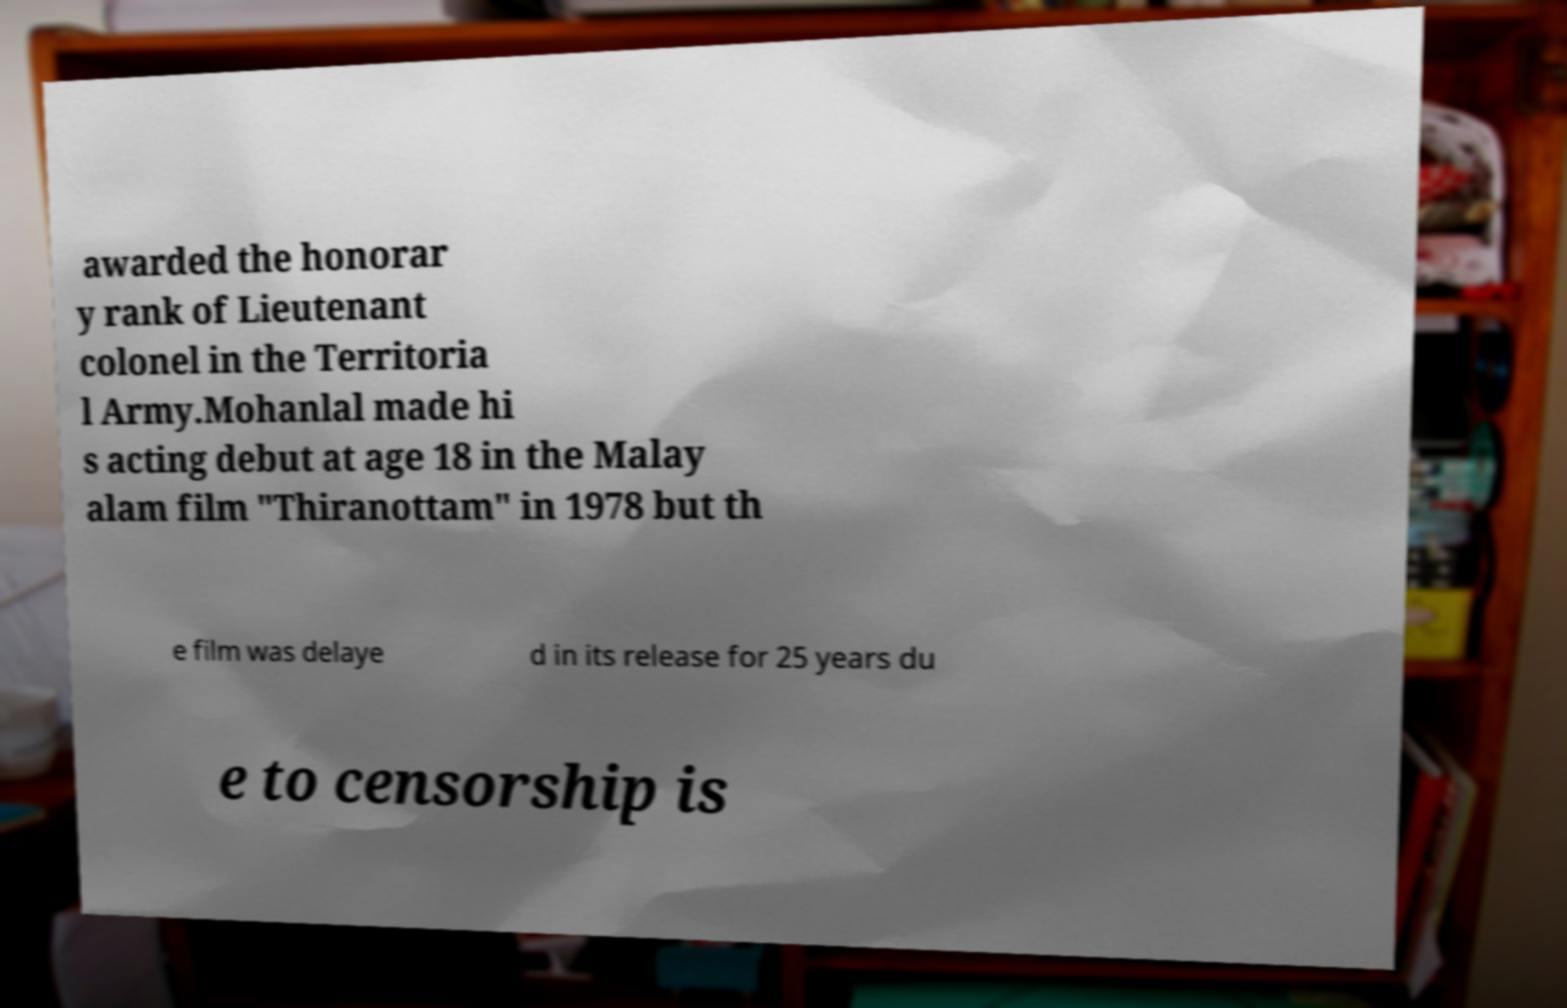What messages or text are displayed in this image? I need them in a readable, typed format. awarded the honorar y rank of Lieutenant colonel in the Territoria l Army.Mohanlal made hi s acting debut at age 18 in the Malay alam film "Thiranottam" in 1978 but th e film was delaye d in its release for 25 years du e to censorship is 